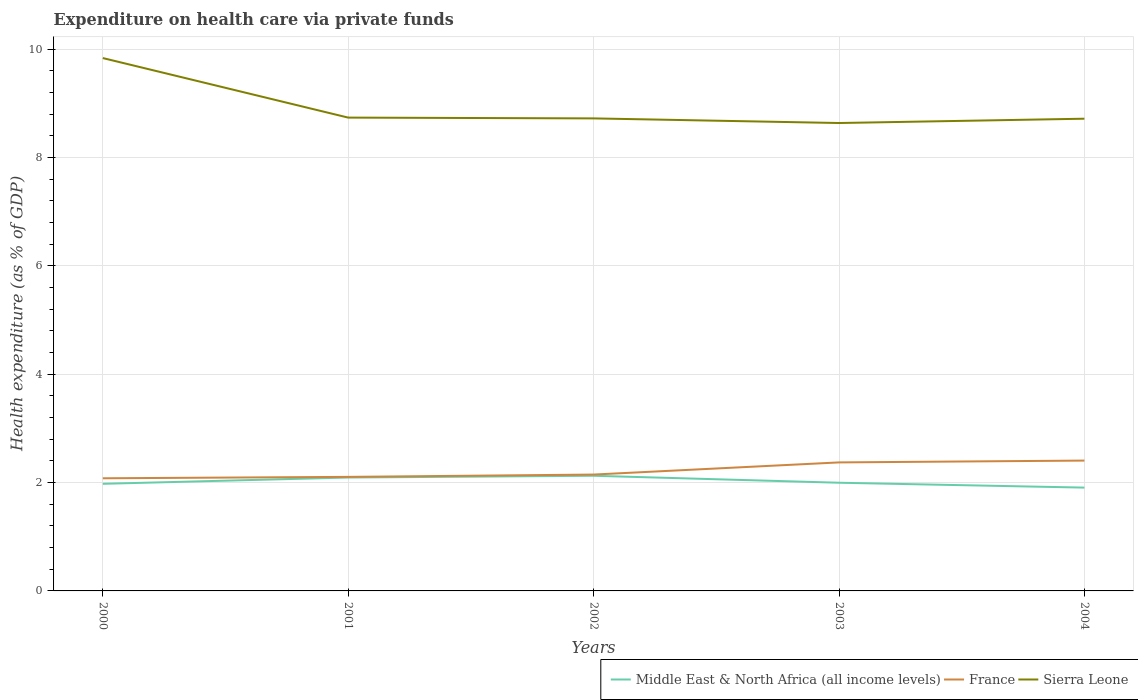How many different coloured lines are there?
Offer a terse response. 3. Does the line corresponding to France intersect with the line corresponding to Sierra Leone?
Make the answer very short. No. Across all years, what is the maximum expenditure made on health care in France?
Make the answer very short. 2.08. In which year was the expenditure made on health care in Middle East & North Africa (all income levels) maximum?
Make the answer very short. 2004. What is the total expenditure made on health care in France in the graph?
Your response must be concise. -0.26. What is the difference between the highest and the second highest expenditure made on health care in Middle East & North Africa (all income levels)?
Your response must be concise. 0.22. What is the difference between two consecutive major ticks on the Y-axis?
Your response must be concise. 2. Does the graph contain any zero values?
Your response must be concise. No. Does the graph contain grids?
Make the answer very short. Yes. How many legend labels are there?
Make the answer very short. 3. How are the legend labels stacked?
Your answer should be very brief. Horizontal. What is the title of the graph?
Ensure brevity in your answer.  Expenditure on health care via private funds. Does "Ireland" appear as one of the legend labels in the graph?
Your answer should be very brief. No. What is the label or title of the Y-axis?
Offer a terse response. Health expenditure (as % of GDP). What is the Health expenditure (as % of GDP) in Middle East & North Africa (all income levels) in 2000?
Keep it short and to the point. 1.98. What is the Health expenditure (as % of GDP) of France in 2000?
Offer a very short reply. 2.08. What is the Health expenditure (as % of GDP) of Sierra Leone in 2000?
Your answer should be compact. 9.84. What is the Health expenditure (as % of GDP) of Middle East & North Africa (all income levels) in 2001?
Your answer should be very brief. 2.09. What is the Health expenditure (as % of GDP) of France in 2001?
Give a very brief answer. 2.11. What is the Health expenditure (as % of GDP) of Sierra Leone in 2001?
Provide a short and direct response. 8.74. What is the Health expenditure (as % of GDP) of Middle East & North Africa (all income levels) in 2002?
Provide a succinct answer. 2.13. What is the Health expenditure (as % of GDP) in France in 2002?
Provide a succinct answer. 2.15. What is the Health expenditure (as % of GDP) in Sierra Leone in 2002?
Provide a short and direct response. 8.72. What is the Health expenditure (as % of GDP) of Middle East & North Africa (all income levels) in 2003?
Your response must be concise. 2. What is the Health expenditure (as % of GDP) in France in 2003?
Ensure brevity in your answer.  2.37. What is the Health expenditure (as % of GDP) of Sierra Leone in 2003?
Ensure brevity in your answer.  8.64. What is the Health expenditure (as % of GDP) of Middle East & North Africa (all income levels) in 2004?
Offer a terse response. 1.91. What is the Health expenditure (as % of GDP) in France in 2004?
Your answer should be compact. 2.41. What is the Health expenditure (as % of GDP) in Sierra Leone in 2004?
Offer a terse response. 8.72. Across all years, what is the maximum Health expenditure (as % of GDP) in Middle East & North Africa (all income levels)?
Keep it short and to the point. 2.13. Across all years, what is the maximum Health expenditure (as % of GDP) in France?
Make the answer very short. 2.41. Across all years, what is the maximum Health expenditure (as % of GDP) in Sierra Leone?
Give a very brief answer. 9.84. Across all years, what is the minimum Health expenditure (as % of GDP) in Middle East & North Africa (all income levels)?
Provide a short and direct response. 1.91. Across all years, what is the minimum Health expenditure (as % of GDP) in France?
Offer a terse response. 2.08. Across all years, what is the minimum Health expenditure (as % of GDP) in Sierra Leone?
Make the answer very short. 8.64. What is the total Health expenditure (as % of GDP) in Middle East & North Africa (all income levels) in the graph?
Provide a short and direct response. 10.1. What is the total Health expenditure (as % of GDP) of France in the graph?
Ensure brevity in your answer.  11.11. What is the total Health expenditure (as % of GDP) in Sierra Leone in the graph?
Keep it short and to the point. 44.65. What is the difference between the Health expenditure (as % of GDP) of Middle East & North Africa (all income levels) in 2000 and that in 2001?
Your answer should be very brief. -0.12. What is the difference between the Health expenditure (as % of GDP) of France in 2000 and that in 2001?
Ensure brevity in your answer.  -0.03. What is the difference between the Health expenditure (as % of GDP) in Sierra Leone in 2000 and that in 2001?
Ensure brevity in your answer.  1.1. What is the difference between the Health expenditure (as % of GDP) in Middle East & North Africa (all income levels) in 2000 and that in 2002?
Give a very brief answer. -0.15. What is the difference between the Health expenditure (as % of GDP) in France in 2000 and that in 2002?
Keep it short and to the point. -0.07. What is the difference between the Health expenditure (as % of GDP) of Sierra Leone in 2000 and that in 2002?
Offer a very short reply. 1.11. What is the difference between the Health expenditure (as % of GDP) of Middle East & North Africa (all income levels) in 2000 and that in 2003?
Make the answer very short. -0.02. What is the difference between the Health expenditure (as % of GDP) of France in 2000 and that in 2003?
Provide a succinct answer. -0.29. What is the difference between the Health expenditure (as % of GDP) of Sierra Leone in 2000 and that in 2003?
Your answer should be compact. 1.2. What is the difference between the Health expenditure (as % of GDP) of Middle East & North Africa (all income levels) in 2000 and that in 2004?
Your response must be concise. 0.07. What is the difference between the Health expenditure (as % of GDP) in France in 2000 and that in 2004?
Make the answer very short. -0.33. What is the difference between the Health expenditure (as % of GDP) of Sierra Leone in 2000 and that in 2004?
Your answer should be compact. 1.12. What is the difference between the Health expenditure (as % of GDP) of Middle East & North Africa (all income levels) in 2001 and that in 2002?
Offer a terse response. -0.03. What is the difference between the Health expenditure (as % of GDP) of France in 2001 and that in 2002?
Offer a very short reply. -0.04. What is the difference between the Health expenditure (as % of GDP) in Sierra Leone in 2001 and that in 2002?
Make the answer very short. 0.01. What is the difference between the Health expenditure (as % of GDP) of Middle East & North Africa (all income levels) in 2001 and that in 2003?
Provide a short and direct response. 0.1. What is the difference between the Health expenditure (as % of GDP) in France in 2001 and that in 2003?
Your answer should be very brief. -0.27. What is the difference between the Health expenditure (as % of GDP) in Sierra Leone in 2001 and that in 2003?
Ensure brevity in your answer.  0.1. What is the difference between the Health expenditure (as % of GDP) in Middle East & North Africa (all income levels) in 2001 and that in 2004?
Your response must be concise. 0.19. What is the difference between the Health expenditure (as % of GDP) of France in 2001 and that in 2004?
Your answer should be very brief. -0.3. What is the difference between the Health expenditure (as % of GDP) of Sierra Leone in 2001 and that in 2004?
Give a very brief answer. 0.02. What is the difference between the Health expenditure (as % of GDP) in Middle East & North Africa (all income levels) in 2002 and that in 2003?
Offer a terse response. 0.13. What is the difference between the Health expenditure (as % of GDP) of France in 2002 and that in 2003?
Your answer should be compact. -0.22. What is the difference between the Health expenditure (as % of GDP) in Sierra Leone in 2002 and that in 2003?
Provide a succinct answer. 0.09. What is the difference between the Health expenditure (as % of GDP) of Middle East & North Africa (all income levels) in 2002 and that in 2004?
Make the answer very short. 0.22. What is the difference between the Health expenditure (as % of GDP) in France in 2002 and that in 2004?
Keep it short and to the point. -0.26. What is the difference between the Health expenditure (as % of GDP) in Sierra Leone in 2002 and that in 2004?
Offer a terse response. 0.01. What is the difference between the Health expenditure (as % of GDP) of Middle East & North Africa (all income levels) in 2003 and that in 2004?
Your answer should be compact. 0.09. What is the difference between the Health expenditure (as % of GDP) in France in 2003 and that in 2004?
Offer a terse response. -0.03. What is the difference between the Health expenditure (as % of GDP) in Sierra Leone in 2003 and that in 2004?
Ensure brevity in your answer.  -0.08. What is the difference between the Health expenditure (as % of GDP) in Middle East & North Africa (all income levels) in 2000 and the Health expenditure (as % of GDP) in France in 2001?
Give a very brief answer. -0.13. What is the difference between the Health expenditure (as % of GDP) of Middle East & North Africa (all income levels) in 2000 and the Health expenditure (as % of GDP) of Sierra Leone in 2001?
Ensure brevity in your answer.  -6.76. What is the difference between the Health expenditure (as % of GDP) of France in 2000 and the Health expenditure (as % of GDP) of Sierra Leone in 2001?
Offer a very short reply. -6.66. What is the difference between the Health expenditure (as % of GDP) of Middle East & North Africa (all income levels) in 2000 and the Health expenditure (as % of GDP) of France in 2002?
Make the answer very short. -0.17. What is the difference between the Health expenditure (as % of GDP) of Middle East & North Africa (all income levels) in 2000 and the Health expenditure (as % of GDP) of Sierra Leone in 2002?
Your answer should be very brief. -6.75. What is the difference between the Health expenditure (as % of GDP) in France in 2000 and the Health expenditure (as % of GDP) in Sierra Leone in 2002?
Make the answer very short. -6.64. What is the difference between the Health expenditure (as % of GDP) in Middle East & North Africa (all income levels) in 2000 and the Health expenditure (as % of GDP) in France in 2003?
Keep it short and to the point. -0.4. What is the difference between the Health expenditure (as % of GDP) in Middle East & North Africa (all income levels) in 2000 and the Health expenditure (as % of GDP) in Sierra Leone in 2003?
Your response must be concise. -6.66. What is the difference between the Health expenditure (as % of GDP) of France in 2000 and the Health expenditure (as % of GDP) of Sierra Leone in 2003?
Provide a short and direct response. -6.56. What is the difference between the Health expenditure (as % of GDP) of Middle East & North Africa (all income levels) in 2000 and the Health expenditure (as % of GDP) of France in 2004?
Offer a terse response. -0.43. What is the difference between the Health expenditure (as % of GDP) of Middle East & North Africa (all income levels) in 2000 and the Health expenditure (as % of GDP) of Sierra Leone in 2004?
Make the answer very short. -6.74. What is the difference between the Health expenditure (as % of GDP) in France in 2000 and the Health expenditure (as % of GDP) in Sierra Leone in 2004?
Provide a succinct answer. -6.64. What is the difference between the Health expenditure (as % of GDP) of Middle East & North Africa (all income levels) in 2001 and the Health expenditure (as % of GDP) of France in 2002?
Ensure brevity in your answer.  -0.05. What is the difference between the Health expenditure (as % of GDP) of Middle East & North Africa (all income levels) in 2001 and the Health expenditure (as % of GDP) of Sierra Leone in 2002?
Ensure brevity in your answer.  -6.63. What is the difference between the Health expenditure (as % of GDP) of France in 2001 and the Health expenditure (as % of GDP) of Sierra Leone in 2002?
Ensure brevity in your answer.  -6.62. What is the difference between the Health expenditure (as % of GDP) in Middle East & North Africa (all income levels) in 2001 and the Health expenditure (as % of GDP) in France in 2003?
Your response must be concise. -0.28. What is the difference between the Health expenditure (as % of GDP) in Middle East & North Africa (all income levels) in 2001 and the Health expenditure (as % of GDP) in Sierra Leone in 2003?
Your response must be concise. -6.54. What is the difference between the Health expenditure (as % of GDP) in France in 2001 and the Health expenditure (as % of GDP) in Sierra Leone in 2003?
Offer a very short reply. -6.53. What is the difference between the Health expenditure (as % of GDP) in Middle East & North Africa (all income levels) in 2001 and the Health expenditure (as % of GDP) in France in 2004?
Ensure brevity in your answer.  -0.31. What is the difference between the Health expenditure (as % of GDP) in Middle East & North Africa (all income levels) in 2001 and the Health expenditure (as % of GDP) in Sierra Leone in 2004?
Offer a very short reply. -6.62. What is the difference between the Health expenditure (as % of GDP) of France in 2001 and the Health expenditure (as % of GDP) of Sierra Leone in 2004?
Your answer should be very brief. -6.61. What is the difference between the Health expenditure (as % of GDP) in Middle East & North Africa (all income levels) in 2002 and the Health expenditure (as % of GDP) in France in 2003?
Your answer should be compact. -0.25. What is the difference between the Health expenditure (as % of GDP) in Middle East & North Africa (all income levels) in 2002 and the Health expenditure (as % of GDP) in Sierra Leone in 2003?
Your response must be concise. -6.51. What is the difference between the Health expenditure (as % of GDP) in France in 2002 and the Health expenditure (as % of GDP) in Sierra Leone in 2003?
Ensure brevity in your answer.  -6.49. What is the difference between the Health expenditure (as % of GDP) of Middle East & North Africa (all income levels) in 2002 and the Health expenditure (as % of GDP) of France in 2004?
Your answer should be very brief. -0.28. What is the difference between the Health expenditure (as % of GDP) of Middle East & North Africa (all income levels) in 2002 and the Health expenditure (as % of GDP) of Sierra Leone in 2004?
Provide a succinct answer. -6.59. What is the difference between the Health expenditure (as % of GDP) of France in 2002 and the Health expenditure (as % of GDP) of Sierra Leone in 2004?
Offer a terse response. -6.57. What is the difference between the Health expenditure (as % of GDP) of Middle East & North Africa (all income levels) in 2003 and the Health expenditure (as % of GDP) of France in 2004?
Keep it short and to the point. -0.41. What is the difference between the Health expenditure (as % of GDP) of Middle East & North Africa (all income levels) in 2003 and the Health expenditure (as % of GDP) of Sierra Leone in 2004?
Your response must be concise. -6.72. What is the difference between the Health expenditure (as % of GDP) in France in 2003 and the Health expenditure (as % of GDP) in Sierra Leone in 2004?
Give a very brief answer. -6.34. What is the average Health expenditure (as % of GDP) in Middle East & North Africa (all income levels) per year?
Your response must be concise. 2.02. What is the average Health expenditure (as % of GDP) of France per year?
Offer a terse response. 2.22. What is the average Health expenditure (as % of GDP) of Sierra Leone per year?
Your answer should be compact. 8.93. In the year 2000, what is the difference between the Health expenditure (as % of GDP) in Middle East & North Africa (all income levels) and Health expenditure (as % of GDP) in France?
Your answer should be compact. -0.1. In the year 2000, what is the difference between the Health expenditure (as % of GDP) of Middle East & North Africa (all income levels) and Health expenditure (as % of GDP) of Sierra Leone?
Your answer should be compact. -7.86. In the year 2000, what is the difference between the Health expenditure (as % of GDP) in France and Health expenditure (as % of GDP) in Sierra Leone?
Ensure brevity in your answer.  -7.76. In the year 2001, what is the difference between the Health expenditure (as % of GDP) in Middle East & North Africa (all income levels) and Health expenditure (as % of GDP) in France?
Provide a short and direct response. -0.01. In the year 2001, what is the difference between the Health expenditure (as % of GDP) of Middle East & North Africa (all income levels) and Health expenditure (as % of GDP) of Sierra Leone?
Offer a terse response. -6.64. In the year 2001, what is the difference between the Health expenditure (as % of GDP) in France and Health expenditure (as % of GDP) in Sierra Leone?
Provide a short and direct response. -6.63. In the year 2002, what is the difference between the Health expenditure (as % of GDP) in Middle East & North Africa (all income levels) and Health expenditure (as % of GDP) in France?
Provide a succinct answer. -0.02. In the year 2002, what is the difference between the Health expenditure (as % of GDP) in Middle East & North Africa (all income levels) and Health expenditure (as % of GDP) in Sierra Leone?
Provide a succinct answer. -6.6. In the year 2002, what is the difference between the Health expenditure (as % of GDP) in France and Health expenditure (as % of GDP) in Sierra Leone?
Your response must be concise. -6.57. In the year 2003, what is the difference between the Health expenditure (as % of GDP) in Middle East & North Africa (all income levels) and Health expenditure (as % of GDP) in France?
Offer a very short reply. -0.38. In the year 2003, what is the difference between the Health expenditure (as % of GDP) of Middle East & North Africa (all income levels) and Health expenditure (as % of GDP) of Sierra Leone?
Offer a very short reply. -6.64. In the year 2003, what is the difference between the Health expenditure (as % of GDP) in France and Health expenditure (as % of GDP) in Sierra Leone?
Ensure brevity in your answer.  -6.26. In the year 2004, what is the difference between the Health expenditure (as % of GDP) of Middle East & North Africa (all income levels) and Health expenditure (as % of GDP) of France?
Your response must be concise. -0.5. In the year 2004, what is the difference between the Health expenditure (as % of GDP) in Middle East & North Africa (all income levels) and Health expenditure (as % of GDP) in Sierra Leone?
Provide a short and direct response. -6.81. In the year 2004, what is the difference between the Health expenditure (as % of GDP) in France and Health expenditure (as % of GDP) in Sierra Leone?
Provide a succinct answer. -6.31. What is the ratio of the Health expenditure (as % of GDP) of Middle East & North Africa (all income levels) in 2000 to that in 2001?
Make the answer very short. 0.94. What is the ratio of the Health expenditure (as % of GDP) of France in 2000 to that in 2001?
Your answer should be compact. 0.99. What is the ratio of the Health expenditure (as % of GDP) in Sierra Leone in 2000 to that in 2001?
Your answer should be very brief. 1.13. What is the ratio of the Health expenditure (as % of GDP) in Middle East & North Africa (all income levels) in 2000 to that in 2002?
Provide a short and direct response. 0.93. What is the ratio of the Health expenditure (as % of GDP) in France in 2000 to that in 2002?
Your answer should be compact. 0.97. What is the ratio of the Health expenditure (as % of GDP) of Sierra Leone in 2000 to that in 2002?
Keep it short and to the point. 1.13. What is the ratio of the Health expenditure (as % of GDP) of France in 2000 to that in 2003?
Your answer should be compact. 0.88. What is the ratio of the Health expenditure (as % of GDP) of Sierra Leone in 2000 to that in 2003?
Provide a short and direct response. 1.14. What is the ratio of the Health expenditure (as % of GDP) of Middle East & North Africa (all income levels) in 2000 to that in 2004?
Provide a succinct answer. 1.04. What is the ratio of the Health expenditure (as % of GDP) in France in 2000 to that in 2004?
Offer a very short reply. 0.86. What is the ratio of the Health expenditure (as % of GDP) of Sierra Leone in 2000 to that in 2004?
Ensure brevity in your answer.  1.13. What is the ratio of the Health expenditure (as % of GDP) in Middle East & North Africa (all income levels) in 2001 to that in 2002?
Provide a short and direct response. 0.98. What is the ratio of the Health expenditure (as % of GDP) in France in 2001 to that in 2002?
Provide a succinct answer. 0.98. What is the ratio of the Health expenditure (as % of GDP) in Sierra Leone in 2001 to that in 2002?
Provide a short and direct response. 1. What is the ratio of the Health expenditure (as % of GDP) in Middle East & North Africa (all income levels) in 2001 to that in 2003?
Offer a very short reply. 1.05. What is the ratio of the Health expenditure (as % of GDP) of France in 2001 to that in 2003?
Provide a succinct answer. 0.89. What is the ratio of the Health expenditure (as % of GDP) of Sierra Leone in 2001 to that in 2003?
Offer a very short reply. 1.01. What is the ratio of the Health expenditure (as % of GDP) of Middle East & North Africa (all income levels) in 2001 to that in 2004?
Offer a terse response. 1.1. What is the ratio of the Health expenditure (as % of GDP) of France in 2001 to that in 2004?
Make the answer very short. 0.88. What is the ratio of the Health expenditure (as % of GDP) in Sierra Leone in 2001 to that in 2004?
Your response must be concise. 1. What is the ratio of the Health expenditure (as % of GDP) of Middle East & North Africa (all income levels) in 2002 to that in 2003?
Your response must be concise. 1.06. What is the ratio of the Health expenditure (as % of GDP) in France in 2002 to that in 2003?
Provide a succinct answer. 0.91. What is the ratio of the Health expenditure (as % of GDP) of Sierra Leone in 2002 to that in 2003?
Provide a succinct answer. 1.01. What is the ratio of the Health expenditure (as % of GDP) in Middle East & North Africa (all income levels) in 2002 to that in 2004?
Provide a succinct answer. 1.11. What is the ratio of the Health expenditure (as % of GDP) of France in 2002 to that in 2004?
Give a very brief answer. 0.89. What is the ratio of the Health expenditure (as % of GDP) in Middle East & North Africa (all income levels) in 2003 to that in 2004?
Provide a short and direct response. 1.05. What is the ratio of the Health expenditure (as % of GDP) of France in 2003 to that in 2004?
Offer a terse response. 0.99. What is the ratio of the Health expenditure (as % of GDP) of Sierra Leone in 2003 to that in 2004?
Ensure brevity in your answer.  0.99. What is the difference between the highest and the second highest Health expenditure (as % of GDP) in Middle East & North Africa (all income levels)?
Your response must be concise. 0.03. What is the difference between the highest and the second highest Health expenditure (as % of GDP) of France?
Your response must be concise. 0.03. What is the difference between the highest and the second highest Health expenditure (as % of GDP) in Sierra Leone?
Provide a short and direct response. 1.1. What is the difference between the highest and the lowest Health expenditure (as % of GDP) in Middle East & North Africa (all income levels)?
Give a very brief answer. 0.22. What is the difference between the highest and the lowest Health expenditure (as % of GDP) of France?
Keep it short and to the point. 0.33. What is the difference between the highest and the lowest Health expenditure (as % of GDP) of Sierra Leone?
Keep it short and to the point. 1.2. 